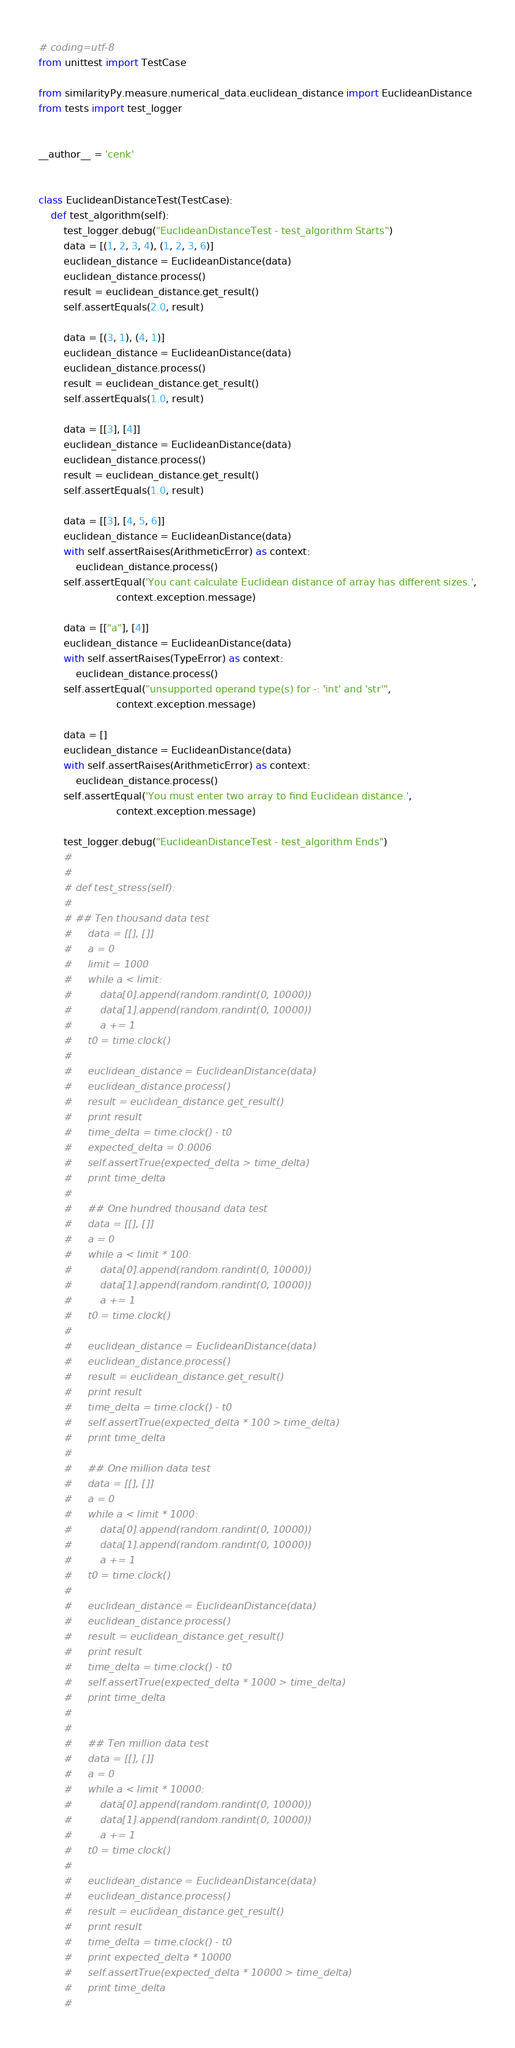Convert code to text. <code><loc_0><loc_0><loc_500><loc_500><_Python_># coding=utf-8
from unittest import TestCase

from similarityPy.measure.numerical_data.euclidean_distance import EuclideanDistance
from tests import test_logger


__author__ = 'cenk'


class EuclideanDistanceTest(TestCase):
    def test_algorithm(self):
        test_logger.debug("EuclideanDistanceTest - test_algorithm Starts")
        data = [(1, 2, 3, 4), (1, 2, 3, 6)]
        euclidean_distance = EuclideanDistance(data)
        euclidean_distance.process()
        result = euclidean_distance.get_result()
        self.assertEquals(2.0, result)

        data = [(3, 1), (4, 1)]
        euclidean_distance = EuclideanDistance(data)
        euclidean_distance.process()
        result = euclidean_distance.get_result()
        self.assertEquals(1.0, result)

        data = [[3], [4]]
        euclidean_distance = EuclideanDistance(data)
        euclidean_distance.process()
        result = euclidean_distance.get_result()
        self.assertEquals(1.0, result)

        data = [[3], [4, 5, 6]]
        euclidean_distance = EuclideanDistance(data)
        with self.assertRaises(ArithmeticError) as context:
            euclidean_distance.process()
        self.assertEqual('You cant calculate Euclidean distance of array has different sizes.',
                         context.exception.message)

        data = [["a"], [4]]
        euclidean_distance = EuclideanDistance(data)
        with self.assertRaises(TypeError) as context:
            euclidean_distance.process()
        self.assertEqual("unsupported operand type(s) for -: 'int' and 'str'",
                         context.exception.message)

        data = []
        euclidean_distance = EuclideanDistance(data)
        with self.assertRaises(ArithmeticError) as context:
            euclidean_distance.process()
        self.assertEqual('You must enter two array to find Euclidean distance.',
                         context.exception.message)

        test_logger.debug("EuclideanDistanceTest - test_algorithm Ends")
        #
        #
        # def test_stress(self):
        #
        # ## Ten thousand data test
        #     data = [[], []]
        #     a = 0
        #     limit = 1000
        #     while a < limit:
        #         data[0].append(random.randint(0, 10000))
        #         data[1].append(random.randint(0, 10000))
        #         a += 1
        #     t0 = time.clock()
        #
        #     euclidean_distance = EuclideanDistance(data)
        #     euclidean_distance.process()
        #     result = euclidean_distance.get_result()
        #     print result
        #     time_delta = time.clock() - t0
        #     expected_delta = 0.0006
        #     self.assertTrue(expected_delta > time_delta)
        #     print time_delta
        #
        #     ## One hundred thousand data test
        #     data = [[], []]
        #     a = 0
        #     while a < limit * 100:
        #         data[0].append(random.randint(0, 10000))
        #         data[1].append(random.randint(0, 10000))
        #         a += 1
        #     t0 = time.clock()
        #
        #     euclidean_distance = EuclideanDistance(data)
        #     euclidean_distance.process()
        #     result = euclidean_distance.get_result()
        #     print result
        #     time_delta = time.clock() - t0
        #     self.assertTrue(expected_delta * 100 > time_delta)
        #     print time_delta
        #
        #     ## One million data test
        #     data = [[], []]
        #     a = 0
        #     while a < limit * 1000:
        #         data[0].append(random.randint(0, 10000))
        #         data[1].append(random.randint(0, 10000))
        #         a += 1
        #     t0 = time.clock()
        #
        #     euclidean_distance = EuclideanDistance(data)
        #     euclidean_distance.process()
        #     result = euclidean_distance.get_result()
        #     print result
        #     time_delta = time.clock() - t0
        #     self.assertTrue(expected_delta * 1000 > time_delta)
        #     print time_delta
        #
        #
        #     ## Ten million data test
        #     data = [[], []]
        #     a = 0
        #     while a < limit * 10000:
        #         data[0].append(random.randint(0, 10000))
        #         data[1].append(random.randint(0, 10000))
        #         a += 1
        #     t0 = time.clock()
        #
        #     euclidean_distance = EuclideanDistance(data)
        #     euclidean_distance.process()
        #     result = euclidean_distance.get_result()
        #     print result
        #     time_delta = time.clock() - t0
        #     print expected_delta * 10000
        #     self.assertTrue(expected_delta * 10000 > time_delta)
        #     print time_delta
        #
</code> 